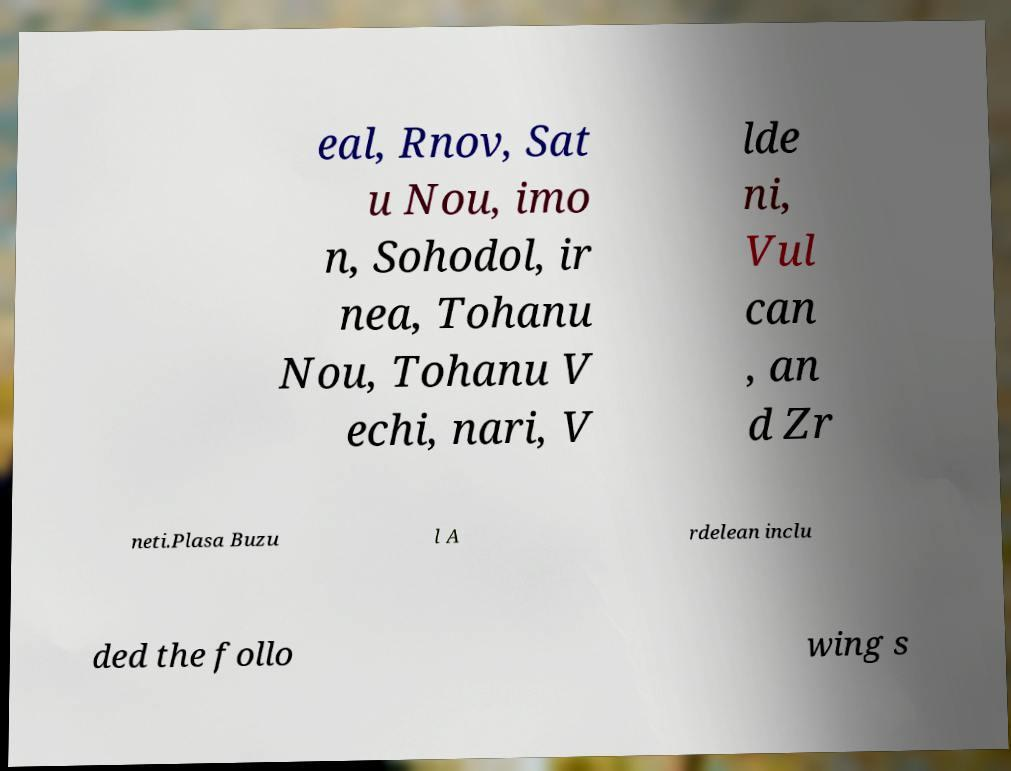Could you assist in decoding the text presented in this image and type it out clearly? eal, Rnov, Sat u Nou, imo n, Sohodol, ir nea, Tohanu Nou, Tohanu V echi, nari, V lde ni, Vul can , an d Zr neti.Plasa Buzu l A rdelean inclu ded the follo wing s 